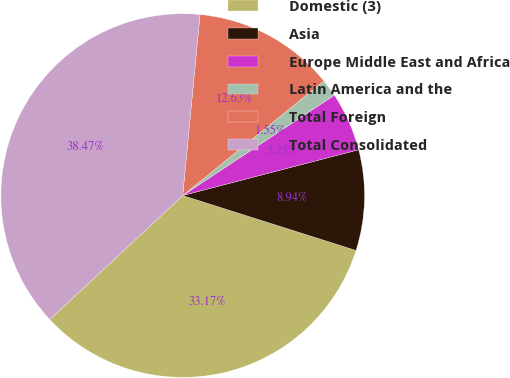<chart> <loc_0><loc_0><loc_500><loc_500><pie_chart><fcel>Domestic (3)<fcel>Asia<fcel>Europe Middle East and Africa<fcel>Latin America and the<fcel>Total Foreign<fcel>Total Consolidated<nl><fcel>33.17%<fcel>8.94%<fcel>5.25%<fcel>1.55%<fcel>12.63%<fcel>38.47%<nl></chart> 